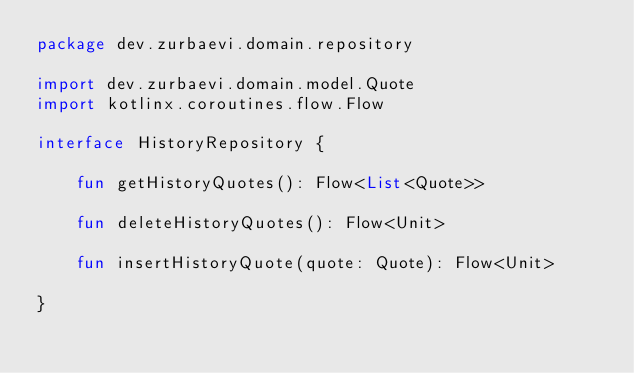Convert code to text. <code><loc_0><loc_0><loc_500><loc_500><_Kotlin_>package dev.zurbaevi.domain.repository

import dev.zurbaevi.domain.model.Quote
import kotlinx.coroutines.flow.Flow

interface HistoryRepository {

    fun getHistoryQuotes(): Flow<List<Quote>>

    fun deleteHistoryQuotes(): Flow<Unit>

    fun insertHistoryQuote(quote: Quote): Flow<Unit>

}</code> 